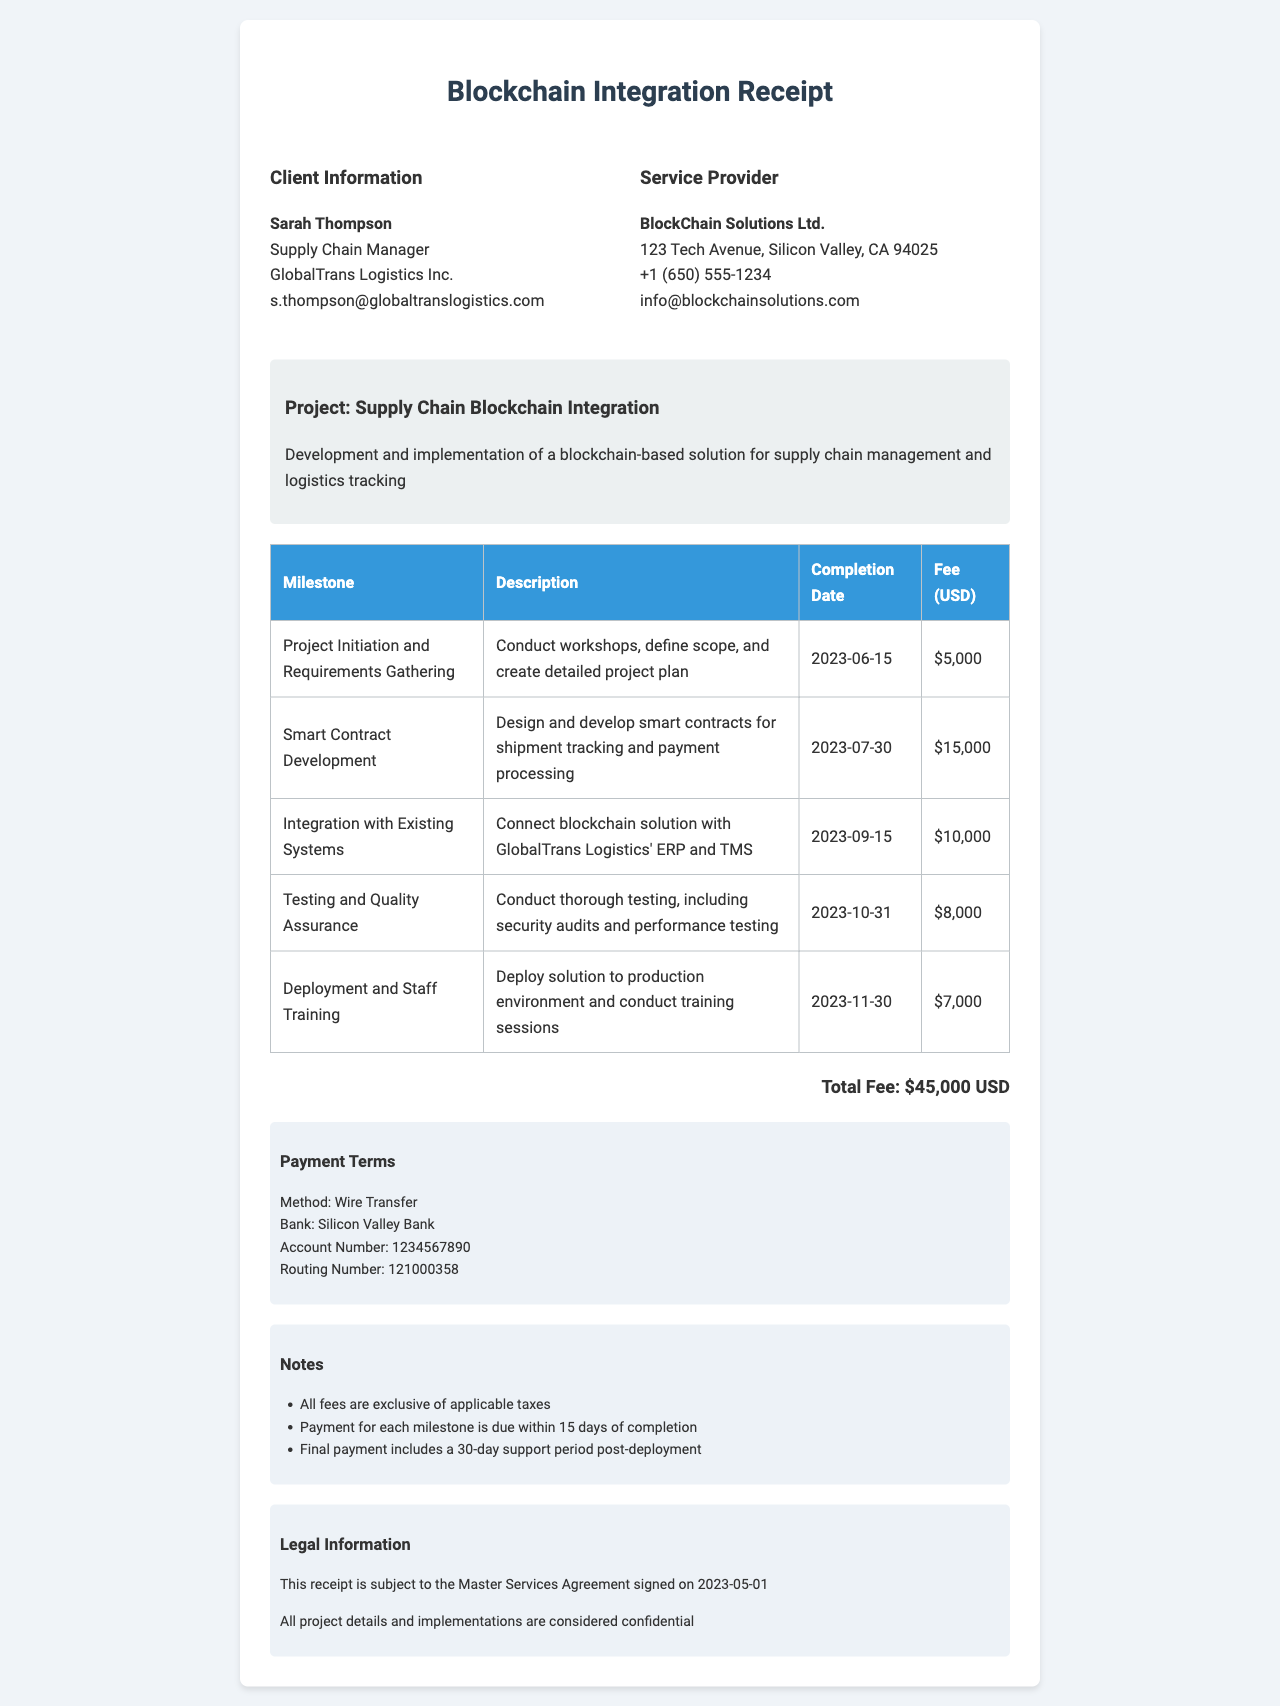what is the receipt number? The receipt number is specified at the top of the document for identification purposes.
Answer: SC2023-0587 who is the client? The client's name and company are provided in the client information section of the document.
Answer: Sarah Thompson, GlobalTrans Logistics Inc what is the total fee for the project? The total fee represents the cumulative amount for all milestones detailed in the document.
Answer: 45000 USD when is the completion date for the Testing and Quality Assurance milestone? The completion date for each milestone is listed alongside the milestone description in the table.
Answer: 2023-10-31 what payment method is specified in the payment terms? The payment method indicates how the payment should be made as mentioned in the document.
Answer: Wire Transfer how many milestones are listed in the document? The number of milestones corresponds to the entries in the milestones table.
Answer: 5 what is included in the notes section? The notes provide additional information regarding fees and payment timelines related to the project.
Answer: All fees are exclusive of applicable taxes, Payment for each milestone is due within 15 days of completion, Final payment includes a 30-day support period post-deployment what is the legal information concerning confidentiality? The legal section includes terms and conditions relevant to the project, particularly around confidentiality.
Answer: All project details and implementations are considered confidential who is the service provider? The name of the service provider is mentioned with their contact details for reference in the document.
Answer: BlockChain Solutions Ltd 